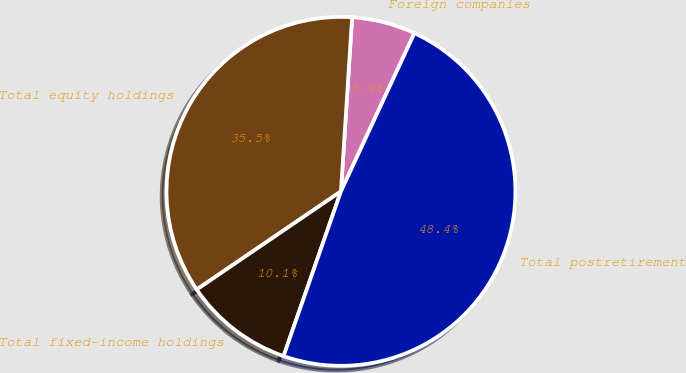Convert chart to OTSL. <chart><loc_0><loc_0><loc_500><loc_500><pie_chart><fcel>Foreign companies<fcel>Total equity holdings<fcel>Total fixed-income holdings<fcel>Total postretirement<nl><fcel>5.9%<fcel>35.53%<fcel>10.15%<fcel>48.42%<nl></chart> 